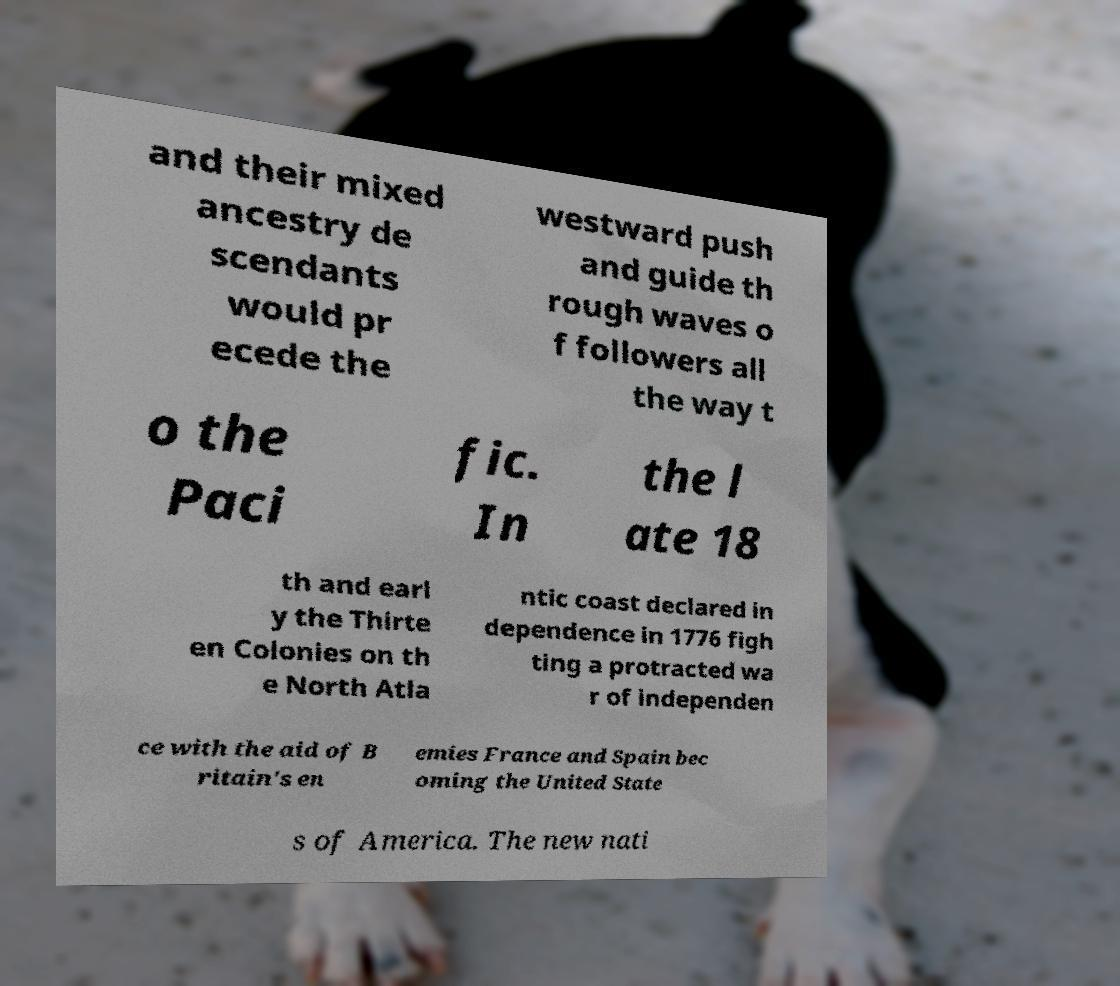There's text embedded in this image that I need extracted. Can you transcribe it verbatim? and their mixed ancestry de scendants would pr ecede the westward push and guide th rough waves o f followers all the way t o the Paci fic. In the l ate 18 th and earl y the Thirte en Colonies on th e North Atla ntic coast declared in dependence in 1776 figh ting a protracted wa r of independen ce with the aid of B ritain's en emies France and Spain bec oming the United State s of America. The new nati 